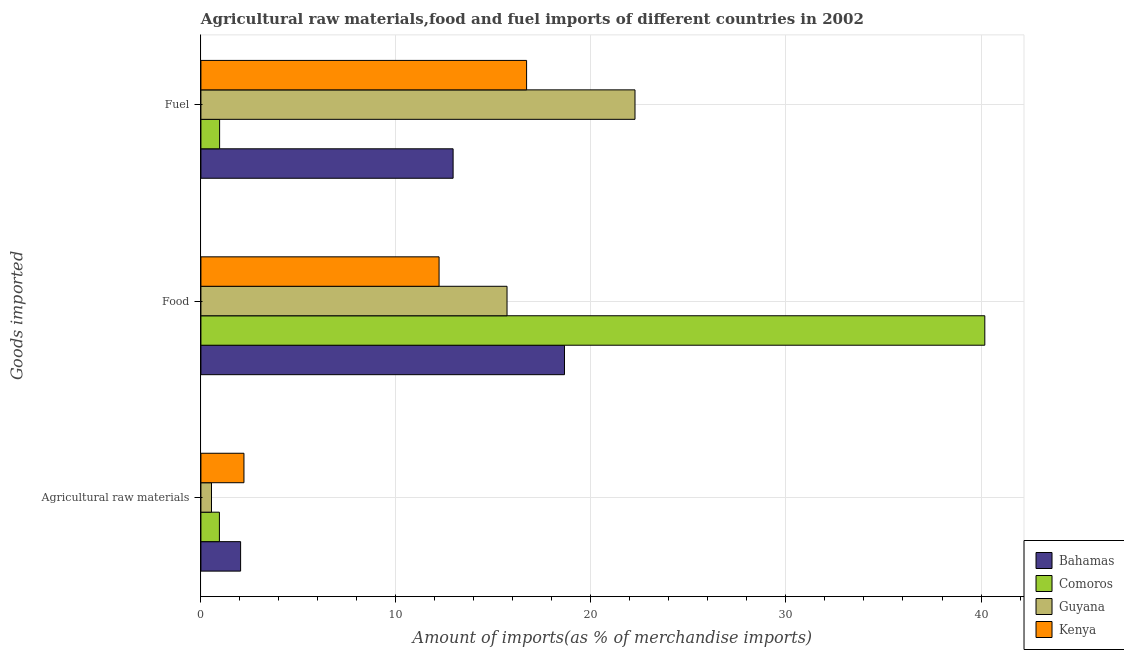How many different coloured bars are there?
Provide a succinct answer. 4. Are the number of bars per tick equal to the number of legend labels?
Your answer should be compact. Yes. What is the label of the 1st group of bars from the top?
Offer a very short reply. Fuel. What is the percentage of food imports in Kenya?
Your answer should be compact. 12.21. Across all countries, what is the maximum percentage of fuel imports?
Offer a very short reply. 22.26. Across all countries, what is the minimum percentage of raw materials imports?
Give a very brief answer. 0.54. In which country was the percentage of raw materials imports maximum?
Ensure brevity in your answer.  Kenya. In which country was the percentage of raw materials imports minimum?
Your response must be concise. Guyana. What is the total percentage of food imports in the graph?
Provide a succinct answer. 86.75. What is the difference between the percentage of fuel imports in Comoros and that in Bahamas?
Offer a terse response. -11.97. What is the difference between the percentage of fuel imports in Comoros and the percentage of food imports in Bahamas?
Ensure brevity in your answer.  -17.68. What is the average percentage of fuel imports per country?
Provide a succinct answer. 13.21. What is the difference between the percentage of raw materials imports and percentage of food imports in Kenya?
Your answer should be very brief. -10.01. In how many countries, is the percentage of raw materials imports greater than 40 %?
Your answer should be very brief. 0. What is the ratio of the percentage of food imports in Kenya to that in Bahamas?
Provide a succinct answer. 0.66. What is the difference between the highest and the second highest percentage of food imports?
Your response must be concise. 21.55. What is the difference between the highest and the lowest percentage of raw materials imports?
Make the answer very short. 1.66. In how many countries, is the percentage of fuel imports greater than the average percentage of fuel imports taken over all countries?
Your answer should be compact. 2. Is the sum of the percentage of fuel imports in Bahamas and Guyana greater than the maximum percentage of food imports across all countries?
Provide a short and direct response. No. What does the 4th bar from the top in Agricultural raw materials represents?
Your response must be concise. Bahamas. What does the 3rd bar from the bottom in Food represents?
Your answer should be very brief. Guyana. How many bars are there?
Provide a short and direct response. 12. Does the graph contain any zero values?
Your answer should be compact. No. How many legend labels are there?
Ensure brevity in your answer.  4. What is the title of the graph?
Provide a succinct answer. Agricultural raw materials,food and fuel imports of different countries in 2002. Does "Spain" appear as one of the legend labels in the graph?
Your answer should be compact. No. What is the label or title of the X-axis?
Provide a short and direct response. Amount of imports(as % of merchandise imports). What is the label or title of the Y-axis?
Make the answer very short. Goods imported. What is the Amount of imports(as % of merchandise imports) of Bahamas in Agricultural raw materials?
Your answer should be very brief. 2.04. What is the Amount of imports(as % of merchandise imports) in Comoros in Agricultural raw materials?
Your answer should be very brief. 0.95. What is the Amount of imports(as % of merchandise imports) in Guyana in Agricultural raw materials?
Provide a short and direct response. 0.54. What is the Amount of imports(as % of merchandise imports) of Kenya in Agricultural raw materials?
Offer a very short reply. 2.21. What is the Amount of imports(as % of merchandise imports) in Bahamas in Food?
Your response must be concise. 18.64. What is the Amount of imports(as % of merchandise imports) in Comoros in Food?
Your response must be concise. 40.2. What is the Amount of imports(as % of merchandise imports) in Guyana in Food?
Ensure brevity in your answer.  15.7. What is the Amount of imports(as % of merchandise imports) in Kenya in Food?
Provide a succinct answer. 12.21. What is the Amount of imports(as % of merchandise imports) in Bahamas in Fuel?
Provide a short and direct response. 12.93. What is the Amount of imports(as % of merchandise imports) in Comoros in Fuel?
Your answer should be very brief. 0.96. What is the Amount of imports(as % of merchandise imports) of Guyana in Fuel?
Your answer should be very brief. 22.26. What is the Amount of imports(as % of merchandise imports) in Kenya in Fuel?
Provide a succinct answer. 16.7. Across all Goods imported, what is the maximum Amount of imports(as % of merchandise imports) in Bahamas?
Provide a short and direct response. 18.64. Across all Goods imported, what is the maximum Amount of imports(as % of merchandise imports) of Comoros?
Give a very brief answer. 40.2. Across all Goods imported, what is the maximum Amount of imports(as % of merchandise imports) of Guyana?
Provide a short and direct response. 22.26. Across all Goods imported, what is the maximum Amount of imports(as % of merchandise imports) in Kenya?
Keep it short and to the point. 16.7. Across all Goods imported, what is the minimum Amount of imports(as % of merchandise imports) of Bahamas?
Ensure brevity in your answer.  2.04. Across all Goods imported, what is the minimum Amount of imports(as % of merchandise imports) of Comoros?
Offer a terse response. 0.95. Across all Goods imported, what is the minimum Amount of imports(as % of merchandise imports) in Guyana?
Offer a terse response. 0.54. Across all Goods imported, what is the minimum Amount of imports(as % of merchandise imports) of Kenya?
Offer a terse response. 2.21. What is the total Amount of imports(as % of merchandise imports) in Bahamas in the graph?
Your response must be concise. 33.61. What is the total Amount of imports(as % of merchandise imports) of Comoros in the graph?
Your answer should be compact. 42.1. What is the total Amount of imports(as % of merchandise imports) of Guyana in the graph?
Provide a succinct answer. 38.5. What is the total Amount of imports(as % of merchandise imports) of Kenya in the graph?
Your answer should be very brief. 31.12. What is the difference between the Amount of imports(as % of merchandise imports) of Bahamas in Agricultural raw materials and that in Food?
Your answer should be compact. -16.61. What is the difference between the Amount of imports(as % of merchandise imports) in Comoros in Agricultural raw materials and that in Food?
Your answer should be very brief. -39.25. What is the difference between the Amount of imports(as % of merchandise imports) of Guyana in Agricultural raw materials and that in Food?
Offer a very short reply. -15.15. What is the difference between the Amount of imports(as % of merchandise imports) of Kenya in Agricultural raw materials and that in Food?
Make the answer very short. -10.01. What is the difference between the Amount of imports(as % of merchandise imports) of Bahamas in Agricultural raw materials and that in Fuel?
Your answer should be very brief. -10.9. What is the difference between the Amount of imports(as % of merchandise imports) in Comoros in Agricultural raw materials and that in Fuel?
Offer a terse response. -0.01. What is the difference between the Amount of imports(as % of merchandise imports) in Guyana in Agricultural raw materials and that in Fuel?
Ensure brevity in your answer.  -21.72. What is the difference between the Amount of imports(as % of merchandise imports) in Kenya in Agricultural raw materials and that in Fuel?
Keep it short and to the point. -14.49. What is the difference between the Amount of imports(as % of merchandise imports) in Bahamas in Food and that in Fuel?
Offer a very short reply. 5.71. What is the difference between the Amount of imports(as % of merchandise imports) of Comoros in Food and that in Fuel?
Keep it short and to the point. 39.24. What is the difference between the Amount of imports(as % of merchandise imports) of Guyana in Food and that in Fuel?
Your answer should be compact. -6.56. What is the difference between the Amount of imports(as % of merchandise imports) of Kenya in Food and that in Fuel?
Your answer should be compact. -4.49. What is the difference between the Amount of imports(as % of merchandise imports) in Bahamas in Agricultural raw materials and the Amount of imports(as % of merchandise imports) in Comoros in Food?
Your response must be concise. -38.16. What is the difference between the Amount of imports(as % of merchandise imports) in Bahamas in Agricultural raw materials and the Amount of imports(as % of merchandise imports) in Guyana in Food?
Provide a succinct answer. -13.66. What is the difference between the Amount of imports(as % of merchandise imports) in Bahamas in Agricultural raw materials and the Amount of imports(as % of merchandise imports) in Kenya in Food?
Make the answer very short. -10.18. What is the difference between the Amount of imports(as % of merchandise imports) in Comoros in Agricultural raw materials and the Amount of imports(as % of merchandise imports) in Guyana in Food?
Keep it short and to the point. -14.75. What is the difference between the Amount of imports(as % of merchandise imports) in Comoros in Agricultural raw materials and the Amount of imports(as % of merchandise imports) in Kenya in Food?
Provide a succinct answer. -11.26. What is the difference between the Amount of imports(as % of merchandise imports) of Guyana in Agricultural raw materials and the Amount of imports(as % of merchandise imports) of Kenya in Food?
Your answer should be very brief. -11.67. What is the difference between the Amount of imports(as % of merchandise imports) in Bahamas in Agricultural raw materials and the Amount of imports(as % of merchandise imports) in Comoros in Fuel?
Make the answer very short. 1.08. What is the difference between the Amount of imports(as % of merchandise imports) in Bahamas in Agricultural raw materials and the Amount of imports(as % of merchandise imports) in Guyana in Fuel?
Give a very brief answer. -20.22. What is the difference between the Amount of imports(as % of merchandise imports) of Bahamas in Agricultural raw materials and the Amount of imports(as % of merchandise imports) of Kenya in Fuel?
Your answer should be very brief. -14.66. What is the difference between the Amount of imports(as % of merchandise imports) in Comoros in Agricultural raw materials and the Amount of imports(as % of merchandise imports) in Guyana in Fuel?
Offer a very short reply. -21.31. What is the difference between the Amount of imports(as % of merchandise imports) of Comoros in Agricultural raw materials and the Amount of imports(as % of merchandise imports) of Kenya in Fuel?
Ensure brevity in your answer.  -15.75. What is the difference between the Amount of imports(as % of merchandise imports) of Guyana in Agricultural raw materials and the Amount of imports(as % of merchandise imports) of Kenya in Fuel?
Ensure brevity in your answer.  -16.16. What is the difference between the Amount of imports(as % of merchandise imports) of Bahamas in Food and the Amount of imports(as % of merchandise imports) of Comoros in Fuel?
Give a very brief answer. 17.68. What is the difference between the Amount of imports(as % of merchandise imports) of Bahamas in Food and the Amount of imports(as % of merchandise imports) of Guyana in Fuel?
Your response must be concise. -3.62. What is the difference between the Amount of imports(as % of merchandise imports) in Bahamas in Food and the Amount of imports(as % of merchandise imports) in Kenya in Fuel?
Keep it short and to the point. 1.94. What is the difference between the Amount of imports(as % of merchandise imports) in Comoros in Food and the Amount of imports(as % of merchandise imports) in Guyana in Fuel?
Offer a terse response. 17.94. What is the difference between the Amount of imports(as % of merchandise imports) in Comoros in Food and the Amount of imports(as % of merchandise imports) in Kenya in Fuel?
Your response must be concise. 23.5. What is the difference between the Amount of imports(as % of merchandise imports) of Guyana in Food and the Amount of imports(as % of merchandise imports) of Kenya in Fuel?
Offer a very short reply. -1. What is the average Amount of imports(as % of merchandise imports) in Bahamas per Goods imported?
Ensure brevity in your answer.  11.2. What is the average Amount of imports(as % of merchandise imports) in Comoros per Goods imported?
Your answer should be very brief. 14.03. What is the average Amount of imports(as % of merchandise imports) of Guyana per Goods imported?
Your answer should be very brief. 12.83. What is the average Amount of imports(as % of merchandise imports) in Kenya per Goods imported?
Your answer should be very brief. 10.37. What is the difference between the Amount of imports(as % of merchandise imports) of Bahamas and Amount of imports(as % of merchandise imports) of Comoros in Agricultural raw materials?
Keep it short and to the point. 1.09. What is the difference between the Amount of imports(as % of merchandise imports) in Bahamas and Amount of imports(as % of merchandise imports) in Guyana in Agricultural raw materials?
Keep it short and to the point. 1.49. What is the difference between the Amount of imports(as % of merchandise imports) of Bahamas and Amount of imports(as % of merchandise imports) of Kenya in Agricultural raw materials?
Offer a very short reply. -0.17. What is the difference between the Amount of imports(as % of merchandise imports) of Comoros and Amount of imports(as % of merchandise imports) of Guyana in Agricultural raw materials?
Keep it short and to the point. 0.41. What is the difference between the Amount of imports(as % of merchandise imports) of Comoros and Amount of imports(as % of merchandise imports) of Kenya in Agricultural raw materials?
Make the answer very short. -1.26. What is the difference between the Amount of imports(as % of merchandise imports) of Guyana and Amount of imports(as % of merchandise imports) of Kenya in Agricultural raw materials?
Keep it short and to the point. -1.66. What is the difference between the Amount of imports(as % of merchandise imports) in Bahamas and Amount of imports(as % of merchandise imports) in Comoros in Food?
Your response must be concise. -21.55. What is the difference between the Amount of imports(as % of merchandise imports) in Bahamas and Amount of imports(as % of merchandise imports) in Guyana in Food?
Offer a terse response. 2.95. What is the difference between the Amount of imports(as % of merchandise imports) of Bahamas and Amount of imports(as % of merchandise imports) of Kenya in Food?
Your response must be concise. 6.43. What is the difference between the Amount of imports(as % of merchandise imports) in Comoros and Amount of imports(as % of merchandise imports) in Guyana in Food?
Your answer should be very brief. 24.5. What is the difference between the Amount of imports(as % of merchandise imports) of Comoros and Amount of imports(as % of merchandise imports) of Kenya in Food?
Offer a very short reply. 27.98. What is the difference between the Amount of imports(as % of merchandise imports) in Guyana and Amount of imports(as % of merchandise imports) in Kenya in Food?
Offer a terse response. 3.48. What is the difference between the Amount of imports(as % of merchandise imports) of Bahamas and Amount of imports(as % of merchandise imports) of Comoros in Fuel?
Give a very brief answer. 11.97. What is the difference between the Amount of imports(as % of merchandise imports) of Bahamas and Amount of imports(as % of merchandise imports) of Guyana in Fuel?
Give a very brief answer. -9.33. What is the difference between the Amount of imports(as % of merchandise imports) of Bahamas and Amount of imports(as % of merchandise imports) of Kenya in Fuel?
Offer a very short reply. -3.77. What is the difference between the Amount of imports(as % of merchandise imports) of Comoros and Amount of imports(as % of merchandise imports) of Guyana in Fuel?
Your answer should be compact. -21.3. What is the difference between the Amount of imports(as % of merchandise imports) of Comoros and Amount of imports(as % of merchandise imports) of Kenya in Fuel?
Your answer should be compact. -15.74. What is the difference between the Amount of imports(as % of merchandise imports) of Guyana and Amount of imports(as % of merchandise imports) of Kenya in Fuel?
Provide a short and direct response. 5.56. What is the ratio of the Amount of imports(as % of merchandise imports) of Bahamas in Agricultural raw materials to that in Food?
Give a very brief answer. 0.11. What is the ratio of the Amount of imports(as % of merchandise imports) in Comoros in Agricultural raw materials to that in Food?
Offer a terse response. 0.02. What is the ratio of the Amount of imports(as % of merchandise imports) of Guyana in Agricultural raw materials to that in Food?
Make the answer very short. 0.03. What is the ratio of the Amount of imports(as % of merchandise imports) in Kenya in Agricultural raw materials to that in Food?
Keep it short and to the point. 0.18. What is the ratio of the Amount of imports(as % of merchandise imports) in Bahamas in Agricultural raw materials to that in Fuel?
Keep it short and to the point. 0.16. What is the ratio of the Amount of imports(as % of merchandise imports) of Guyana in Agricultural raw materials to that in Fuel?
Your answer should be very brief. 0.02. What is the ratio of the Amount of imports(as % of merchandise imports) in Kenya in Agricultural raw materials to that in Fuel?
Offer a very short reply. 0.13. What is the ratio of the Amount of imports(as % of merchandise imports) of Bahamas in Food to that in Fuel?
Offer a very short reply. 1.44. What is the ratio of the Amount of imports(as % of merchandise imports) of Comoros in Food to that in Fuel?
Make the answer very short. 41.93. What is the ratio of the Amount of imports(as % of merchandise imports) of Guyana in Food to that in Fuel?
Offer a very short reply. 0.71. What is the ratio of the Amount of imports(as % of merchandise imports) in Kenya in Food to that in Fuel?
Keep it short and to the point. 0.73. What is the difference between the highest and the second highest Amount of imports(as % of merchandise imports) of Bahamas?
Offer a terse response. 5.71. What is the difference between the highest and the second highest Amount of imports(as % of merchandise imports) in Comoros?
Provide a succinct answer. 39.24. What is the difference between the highest and the second highest Amount of imports(as % of merchandise imports) in Guyana?
Offer a terse response. 6.56. What is the difference between the highest and the second highest Amount of imports(as % of merchandise imports) in Kenya?
Your answer should be very brief. 4.49. What is the difference between the highest and the lowest Amount of imports(as % of merchandise imports) in Bahamas?
Keep it short and to the point. 16.61. What is the difference between the highest and the lowest Amount of imports(as % of merchandise imports) of Comoros?
Ensure brevity in your answer.  39.25. What is the difference between the highest and the lowest Amount of imports(as % of merchandise imports) in Guyana?
Your answer should be very brief. 21.72. What is the difference between the highest and the lowest Amount of imports(as % of merchandise imports) in Kenya?
Your response must be concise. 14.49. 